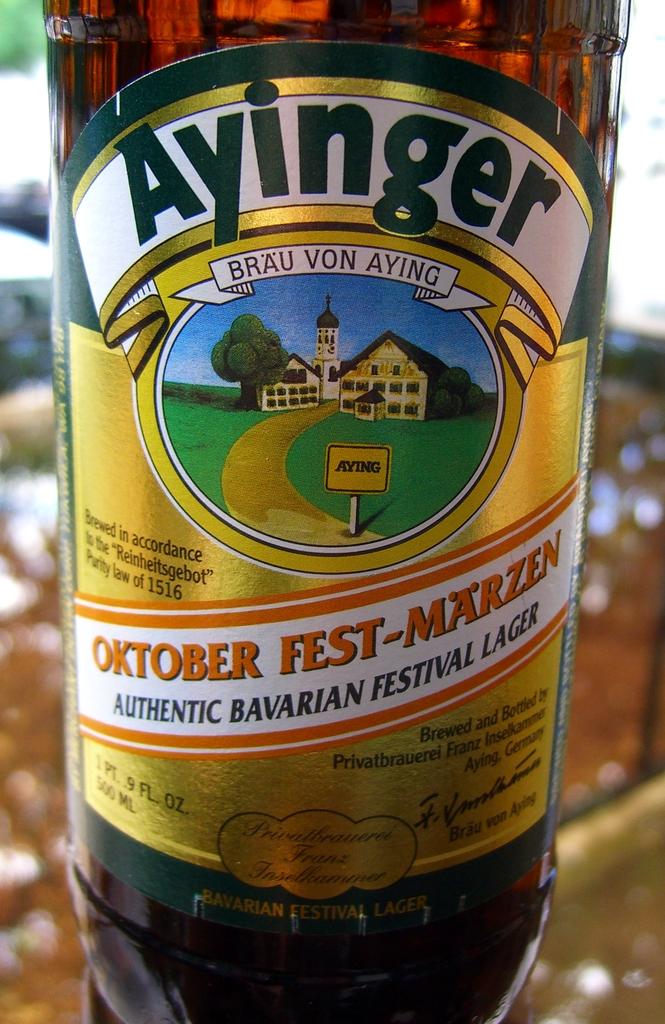What is the motto of this brewery?
Provide a short and direct response. Unanswerable. 